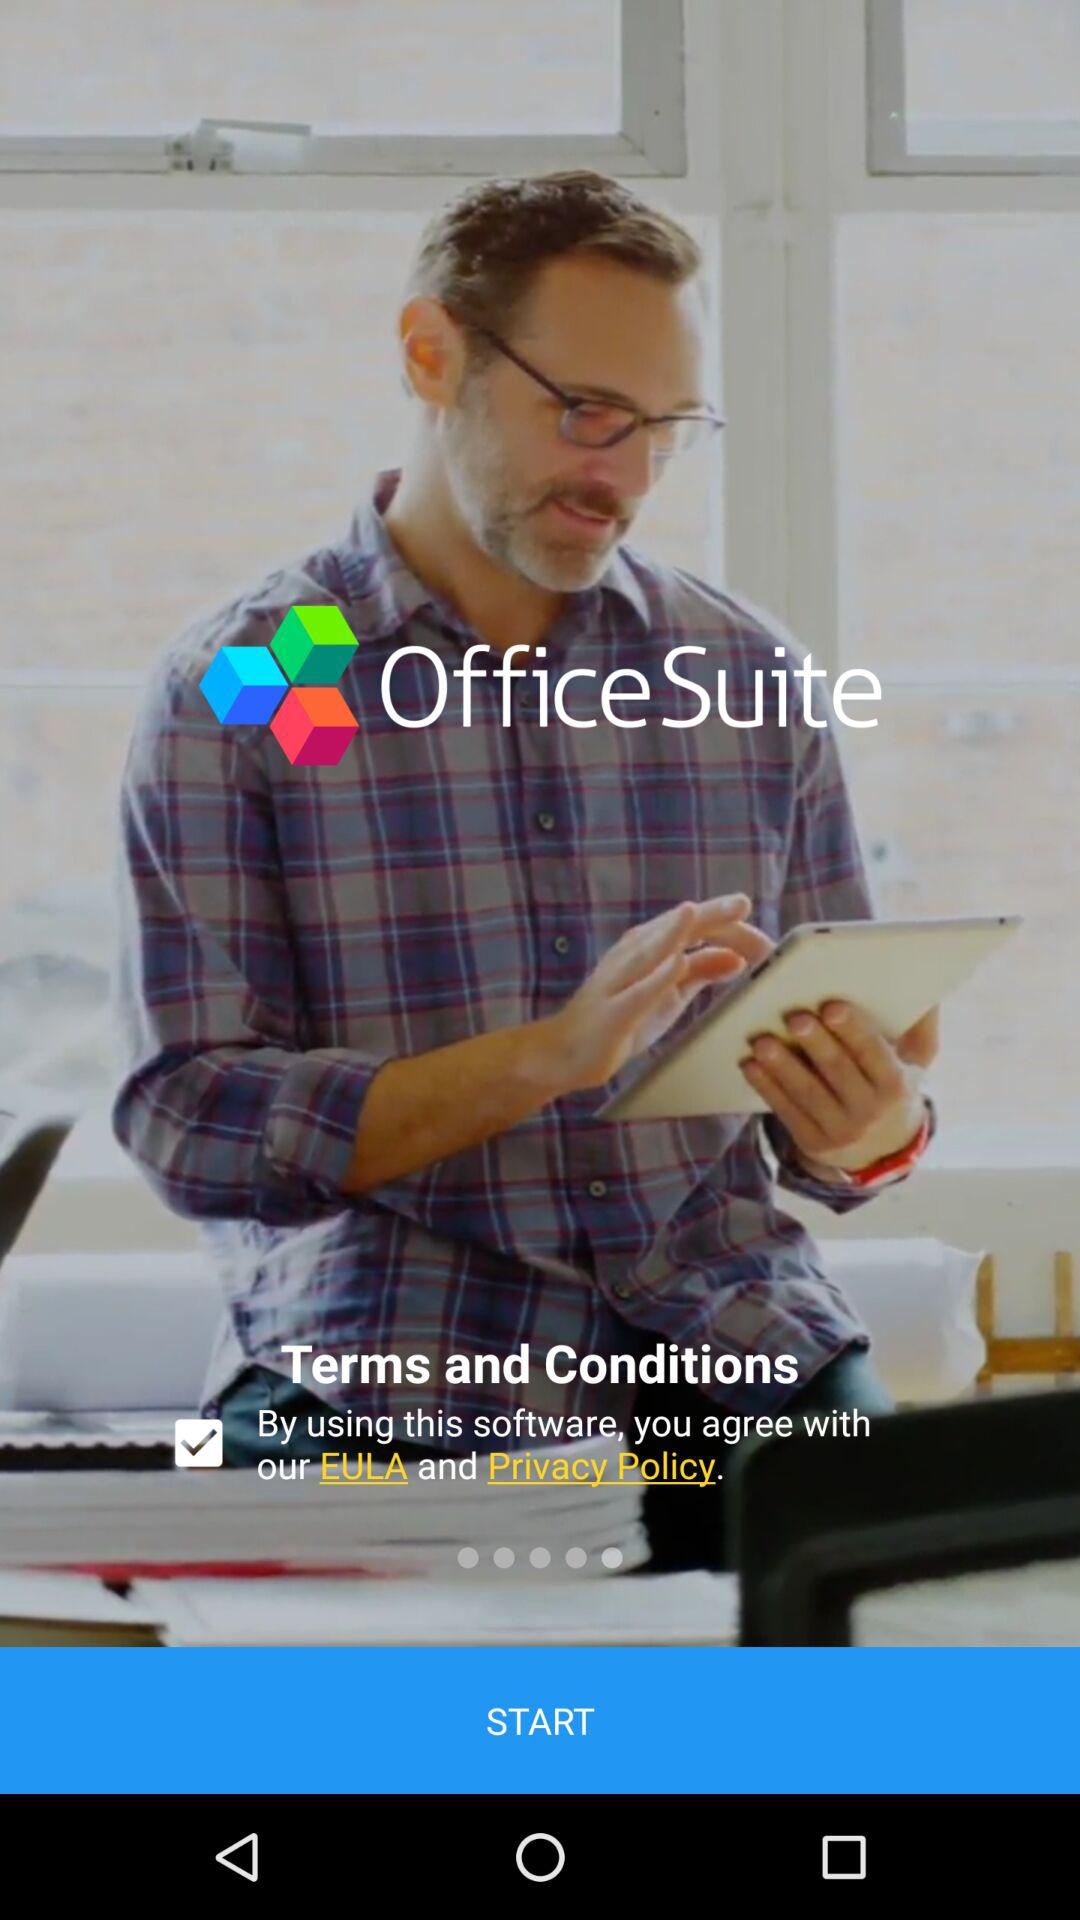What is the status of the option that includes agreement to the “EULA” and “Privacy Policy”? The status is "on". 